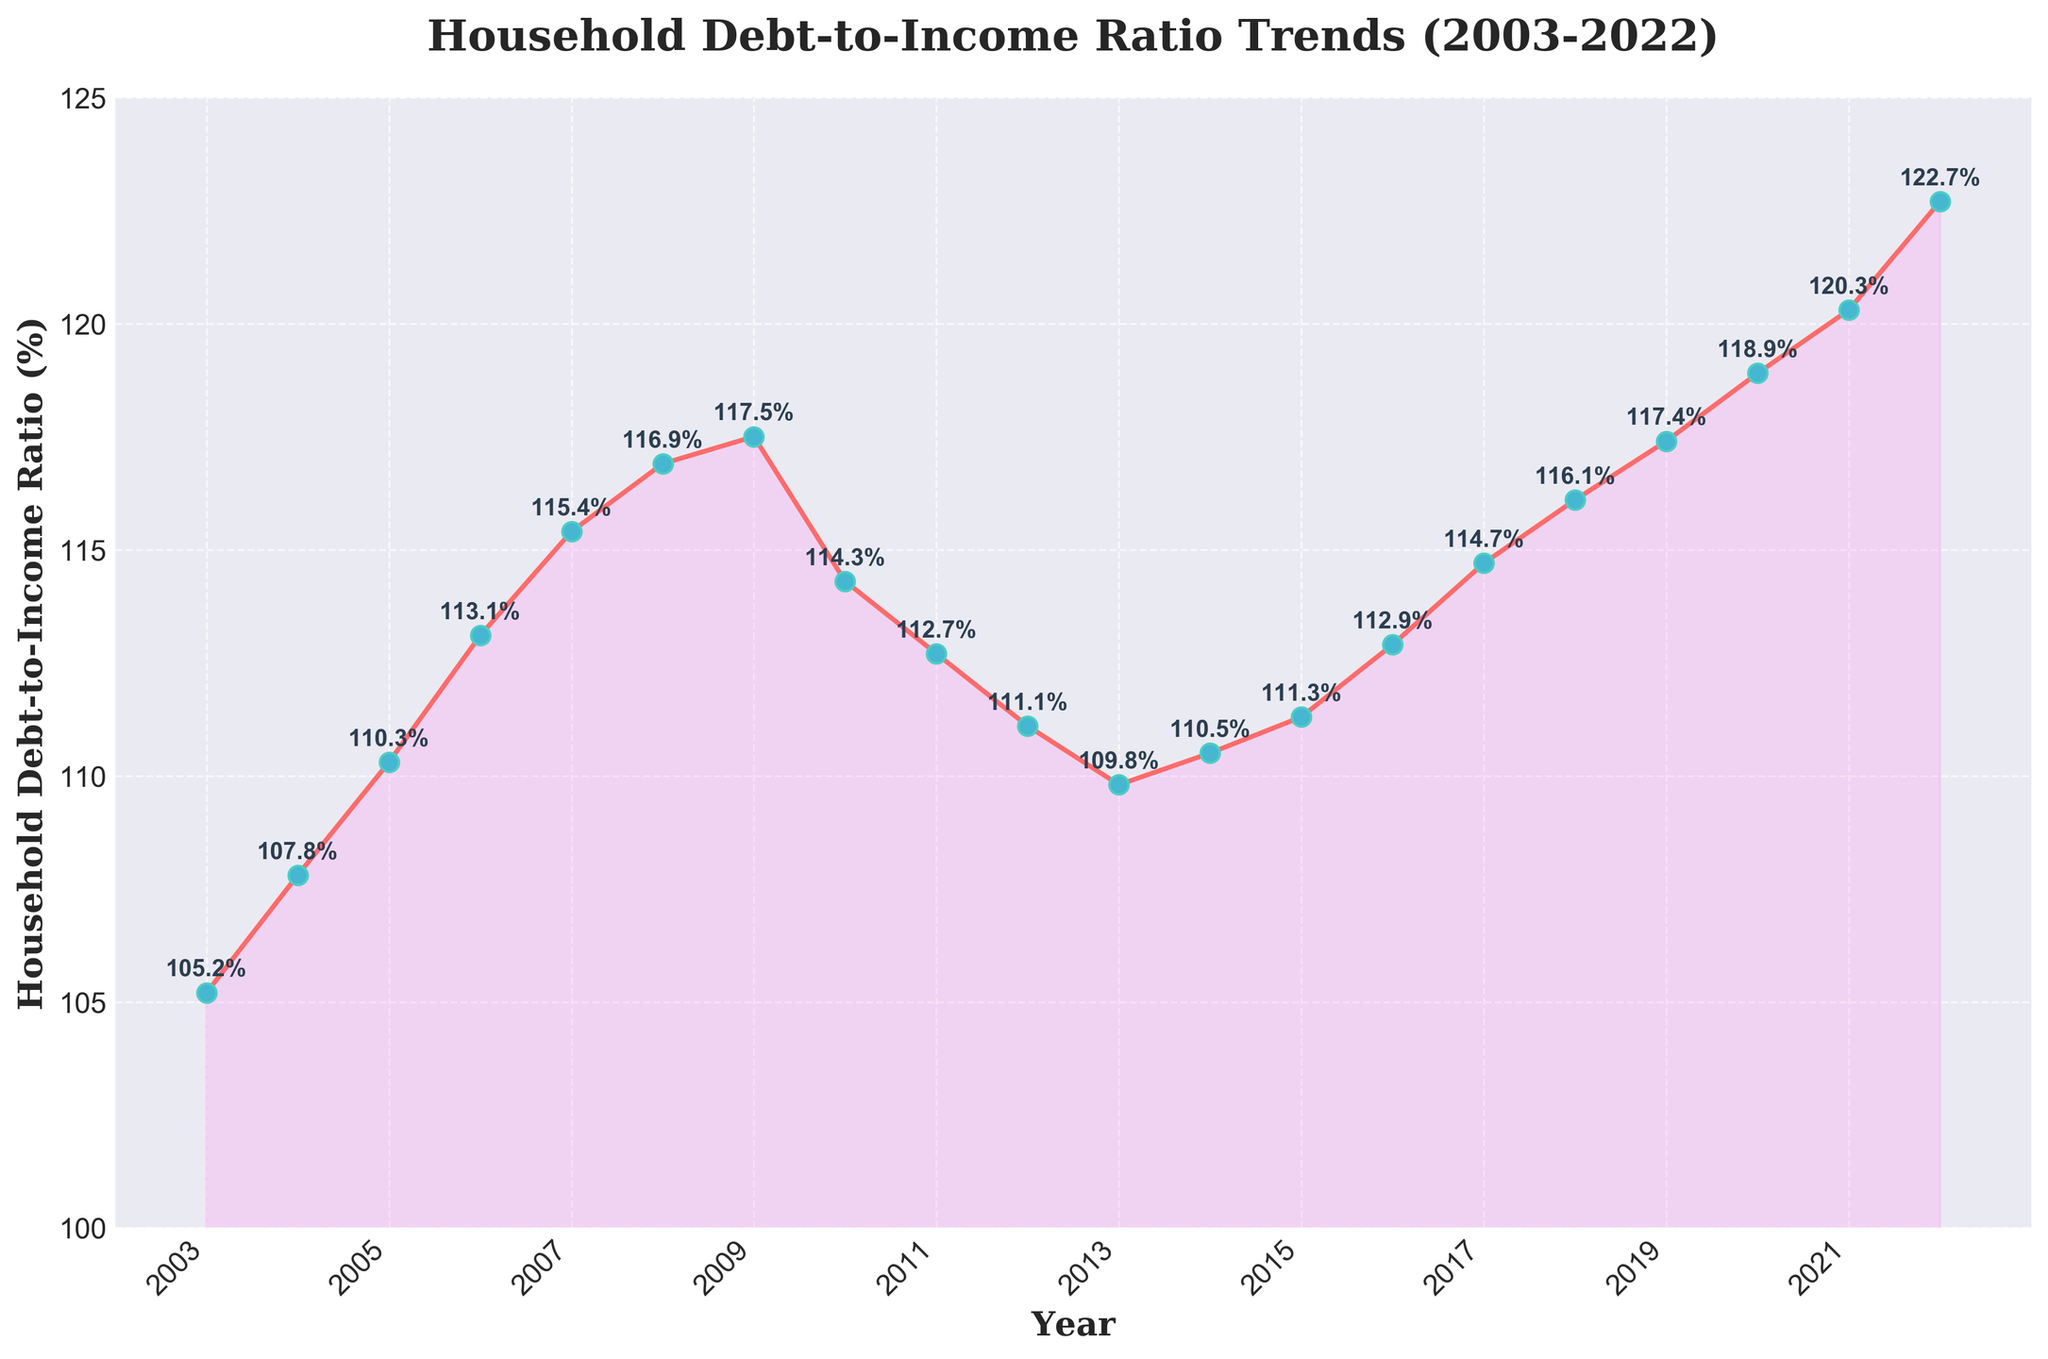What is the title of the plot? The title is typically displayed at the top center of the plot, written in a larger font size and often bolded. In this plot, the title is visible and gives an overview of the data trend being displayed.
Answer: Household Debt-to-Income Ratio Trends (2003-2022) What is the highest Household Debt-to-Income Ratio recorded in the given years? By looking at the y-axis and identifying the peak point of the line graph, we can find the highest recorded ratio. In this plot, the highest point occurs in the final year.
Answer: 122.7 in 2022 Which year experienced the lowest Household Debt-to-Income Ratio? To determine the year with the lowest ratio, we examine the plot for the point closest to the lowest value on the y-axis. This occurs in 2003.
Answer: 2003 How did the Household Debt-to-Income Ratio change between 2009 and 2010? Locate the data points for 2009 and 2010 and observe the change in the ratio by calculating the difference. The ratio decreased from 117.5 to 114.3.
Answer: Decreased by 3.2 Identify the years when the Household Debt-to-Income Ratio was higher than 115%. By checking the y-axis and following the line plot, we can identify the years when the ratio crossed the 115% threshold. These years are visible above the 115% line.
Answer: 2007-2009, 2018-2022 What is the range of the Household Debt-to-Income Ratio over the 20-year period? The range is calculated by subtracting the lowest ratio value from the highest ratio value. The highest is 122.7 and the lowest is 105.2.
Answer: 17.5 How many times did the Household Debt-to-Income Ratio increase consecutively for more than two years? Examine the plot for segments where the line continuously ascends for more than two years. This can be visualized where there are several consecutive upwards movements.
Answer: Three times What is the average Household Debt-to-Income Ratio over the given period? The average can be found by summing all the ratio values and dividing by the number of years. Add all values from 2003 to 2022, then divide by 20.
Answer: 113.695 Between which consecutive years did the Household Debt-to-Income Ratio decrease the most? To find this, compare the differences between consecutive years and identify the largest decrease. The largest drop is from 2009 to 2010.
Answer: 2009-2010 In which period did the Household Debt-to-Income Ratio maintain relatively stable values? Stability can be identified by observing segments of the plot where the line remains near the same level without significant up or down movements. This can be seen between 2011 and 2015.
Answer: 2011-2015 